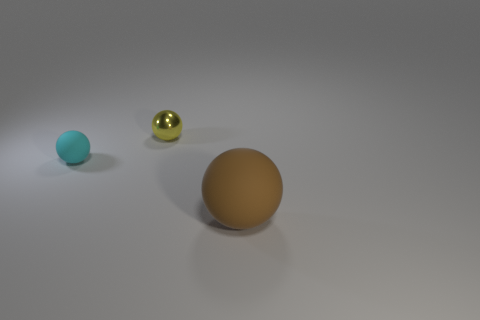Add 2 shiny things. How many objects exist? 5 Add 2 yellow balls. How many yellow balls are left? 3 Add 2 cyan things. How many cyan things exist? 3 Subtract 0 red blocks. How many objects are left? 3 Subtract all tiny brown balls. Subtract all spheres. How many objects are left? 0 